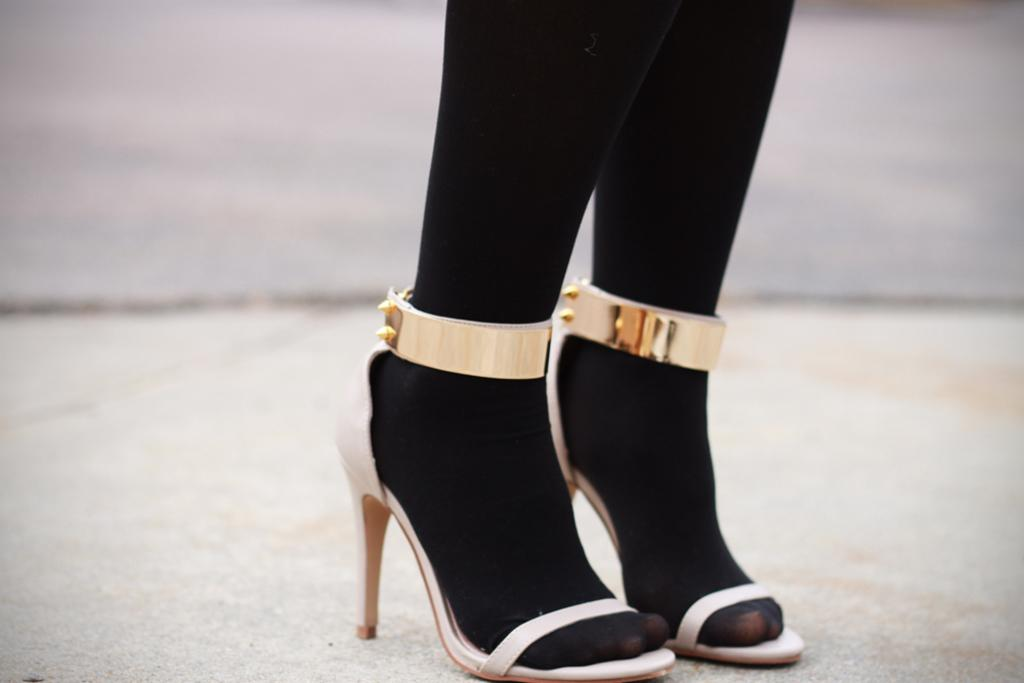What body part is visible in the image? There are legs visible in the image. To whom do the legs belong? The legs belong to a woman. What type of footwear is the woman wearing? The woman is wearing sandals. What type of potato is being served for dinner in the image? There is no potato or dinner present in the image; it only shows a woman's legs and her sandals. How much growth has the woman experienced since the last time she wore these sandals? The image does not provide any information about the woman's growth or previous sandal-wearing experiences. 